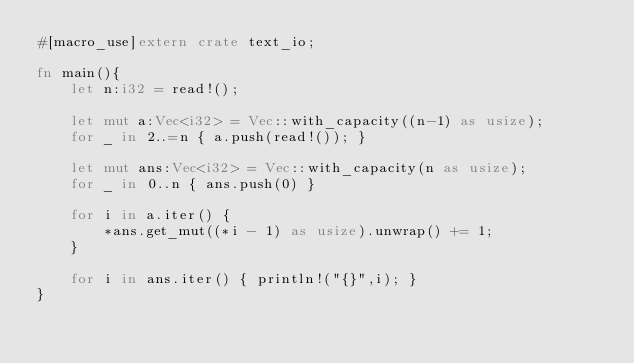<code> <loc_0><loc_0><loc_500><loc_500><_Rust_>#[macro_use]extern crate text_io;

fn main(){
    let n:i32 = read!();

    let mut a:Vec<i32> = Vec::with_capacity((n-1) as usize);
    for _ in 2..=n { a.push(read!()); }

    let mut ans:Vec<i32> = Vec::with_capacity(n as usize);
    for _ in 0..n { ans.push(0) }

    for i in a.iter() {
        *ans.get_mut((*i - 1) as usize).unwrap() += 1;
    }

    for i in ans.iter() { println!("{}",i); }
}</code> 